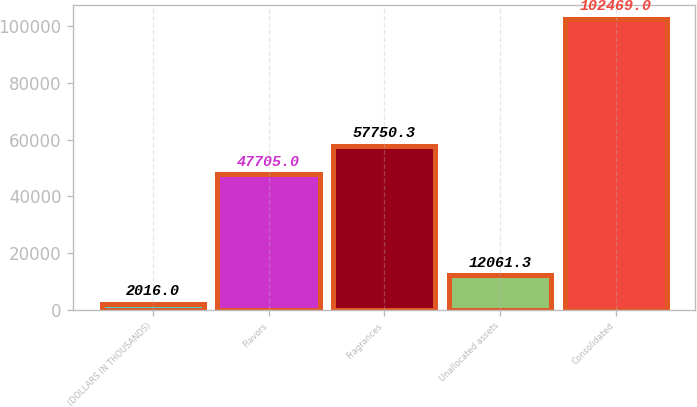<chart> <loc_0><loc_0><loc_500><loc_500><bar_chart><fcel>(DOLLARS IN THOUSANDS)<fcel>Flavors<fcel>Fragrances<fcel>Unallocated assets<fcel>Consolidated<nl><fcel>2016<fcel>47705<fcel>57750.3<fcel>12061.3<fcel>102469<nl></chart> 